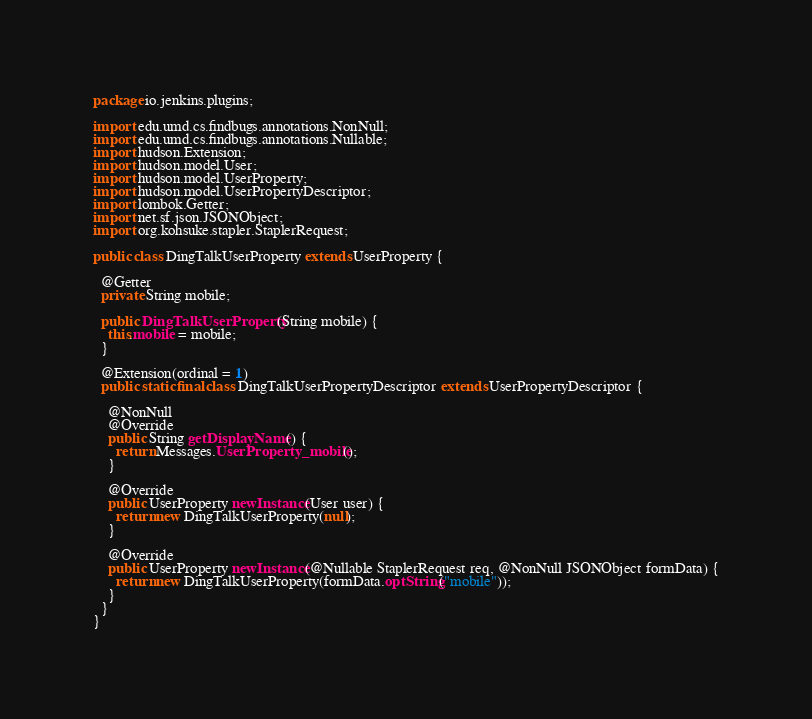<code> <loc_0><loc_0><loc_500><loc_500><_Java_>package io.jenkins.plugins;

import edu.umd.cs.findbugs.annotations.NonNull;
import edu.umd.cs.findbugs.annotations.Nullable;
import hudson.Extension;
import hudson.model.User;
import hudson.model.UserProperty;
import hudson.model.UserPropertyDescriptor;
import lombok.Getter;
import net.sf.json.JSONObject;
import org.kohsuke.stapler.StaplerRequest;

public class DingTalkUserProperty extends UserProperty {

  @Getter
  private String mobile;

  public DingTalkUserProperty(String mobile) {
    this.mobile = mobile;
  }

  @Extension(ordinal = 1)
  public static final class DingTalkUserPropertyDescriptor extends UserPropertyDescriptor {

    @NonNull
    @Override
    public String getDisplayName() {
      return Messages.UserProperty_mobile();
    }

    @Override
    public UserProperty newInstance(User user) {
      return new DingTalkUserProperty(null);
    }

    @Override
    public UserProperty newInstance(@Nullable StaplerRequest req, @NonNull JSONObject formData) {
      return new DingTalkUserProperty(formData.optString("mobile"));
    }
  }
}
</code> 